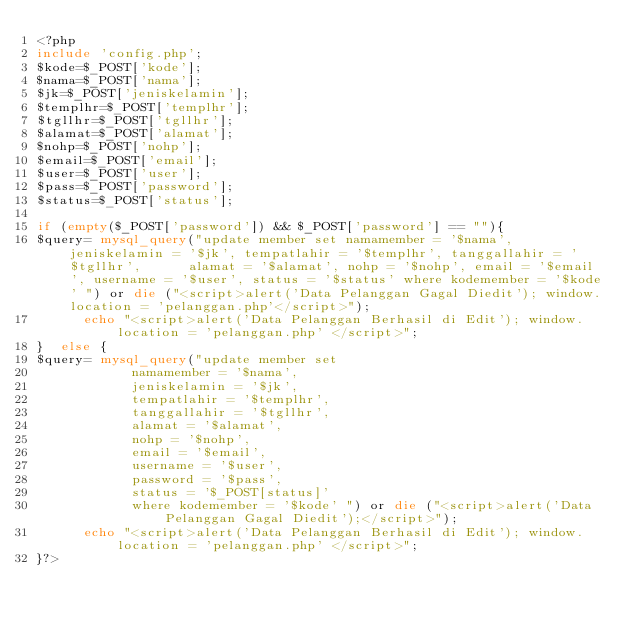<code> <loc_0><loc_0><loc_500><loc_500><_PHP_><?php 
include 'config.php';
$kode=$_POST['kode'];
$nama=$_POST['nama'];
$jk=$_POST['jeniskelamin'];
$templhr=$_POST['templhr'];
$tgllhr=$_POST['tgllhr'];
$alamat=$_POST['alamat'];
$nohp=$_POST['nohp'];
$email=$_POST['email'];
$user=$_POST['user'];
$pass=$_POST['password'];
$status=$_POST['status'];

if (empty($_POST['password']) && $_POST['password'] == ""){
$query= mysql_query("update member set namamember = '$nama', jeniskelamin = '$jk', tempatlahir = '$templhr', tanggallahir = '$tgllhr', 			alamat = '$alamat',	nohp = '$nohp',	email = '$email', username = '$user', status = '$status' where kodemember = '$kode' ") or die ("<script>alert('Data Pelanggan Gagal Diedit'); window.location = 'pelanggan.php'</script>"); 
			echo "<script>alert('Data Pelanggan Berhasil di Edit'); window.location = 'pelanggan.php' </script>";
}  else	{
$query= mysql_query("update member set
						namamember = '$nama',
						jeniskelamin = '$jk',
						tempatlahir = '$templhr',
						tanggallahir = '$tgllhr',
						alamat = '$alamat',
						nohp = '$nohp',
						email = '$email',
						username = '$user',
						password = '$pass',
						status = '$_POST[status]'
						where kodemember = '$kode' ") or die ("<script>alert('Data Pelanggan Gagal Diedit');</script>");
			echo "<script>alert('Data Pelanggan Berhasil di Edit'); window.location = 'pelanggan.php' </script>";
}?></code> 